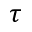<formula> <loc_0><loc_0><loc_500><loc_500>\tau</formula> 